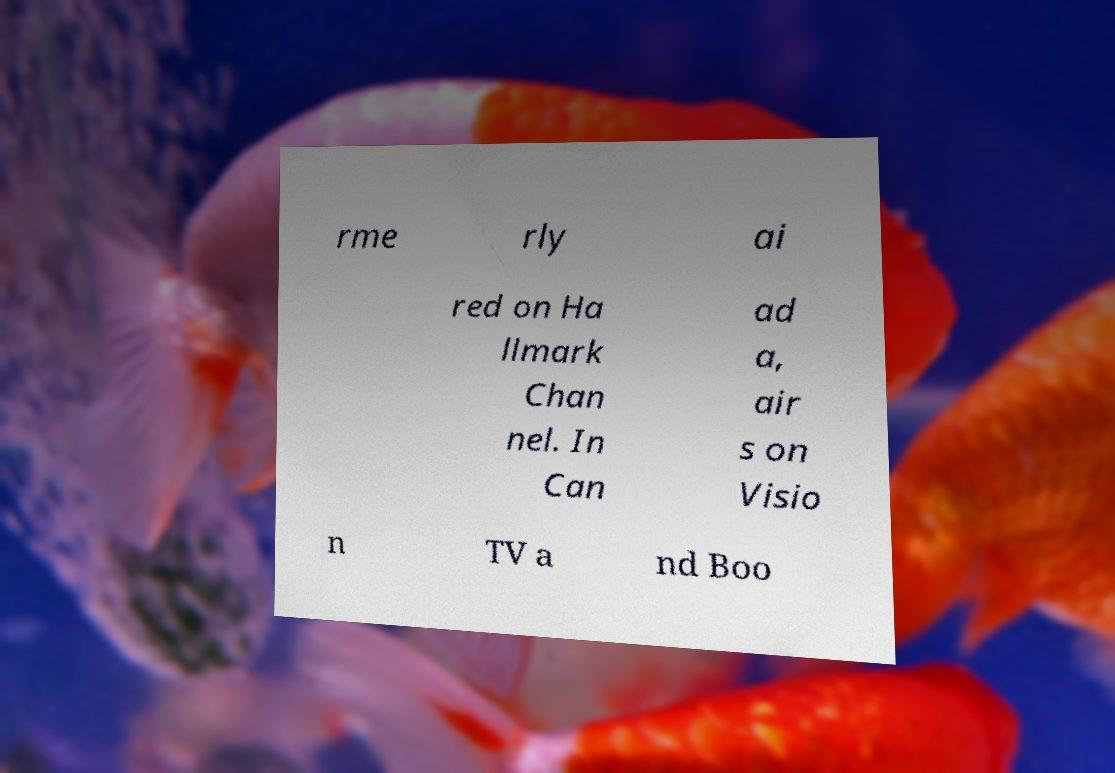Please read and relay the text visible in this image. What does it say? rme rly ai red on Ha llmark Chan nel. In Can ad a, air s on Visio n TV a nd Boo 